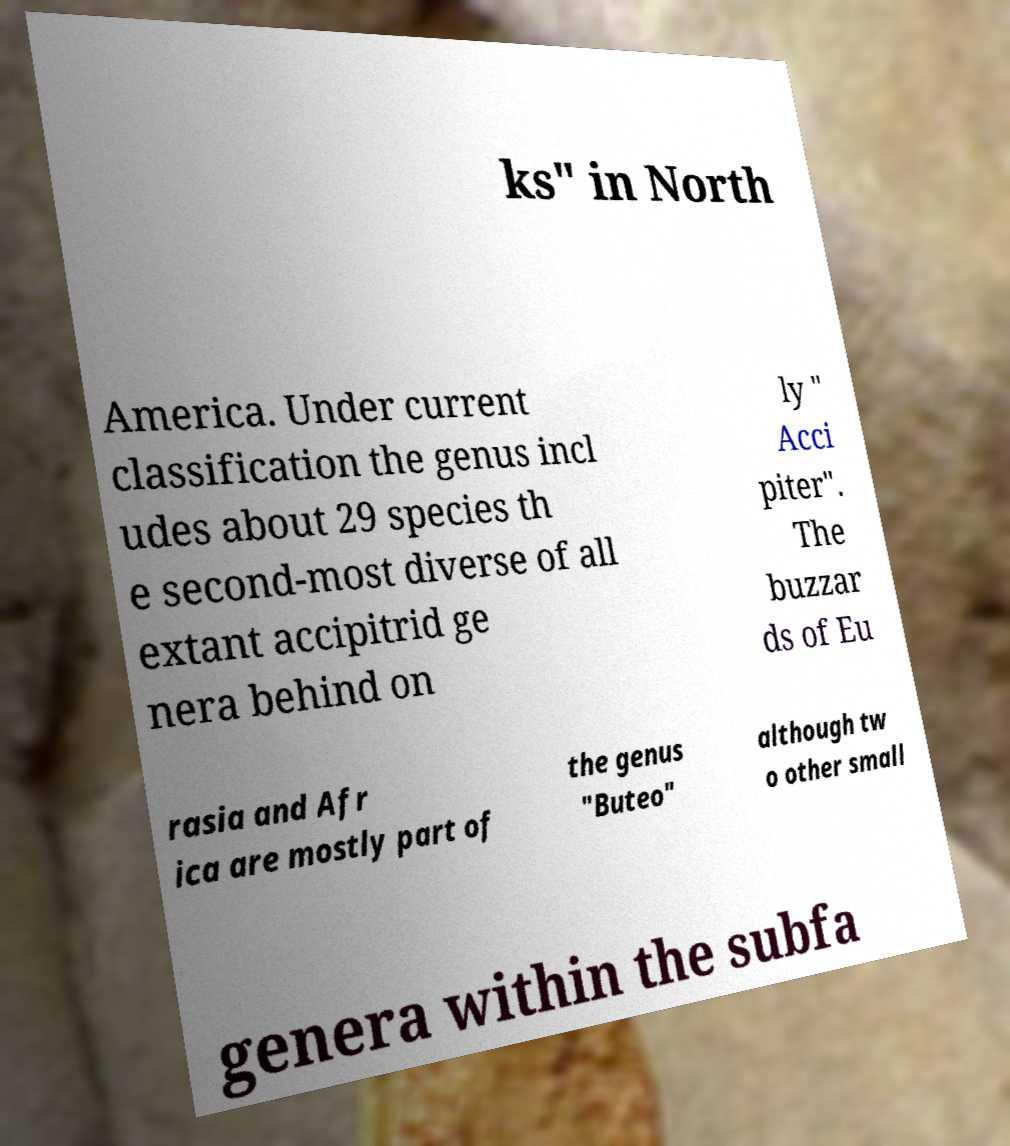Could you extract and type out the text from this image? ks" in North America. Under current classification the genus incl udes about 29 species th e second-most diverse of all extant accipitrid ge nera behind on ly " Acci piter". The buzzar ds of Eu rasia and Afr ica are mostly part of the genus "Buteo" although tw o other small genera within the subfa 